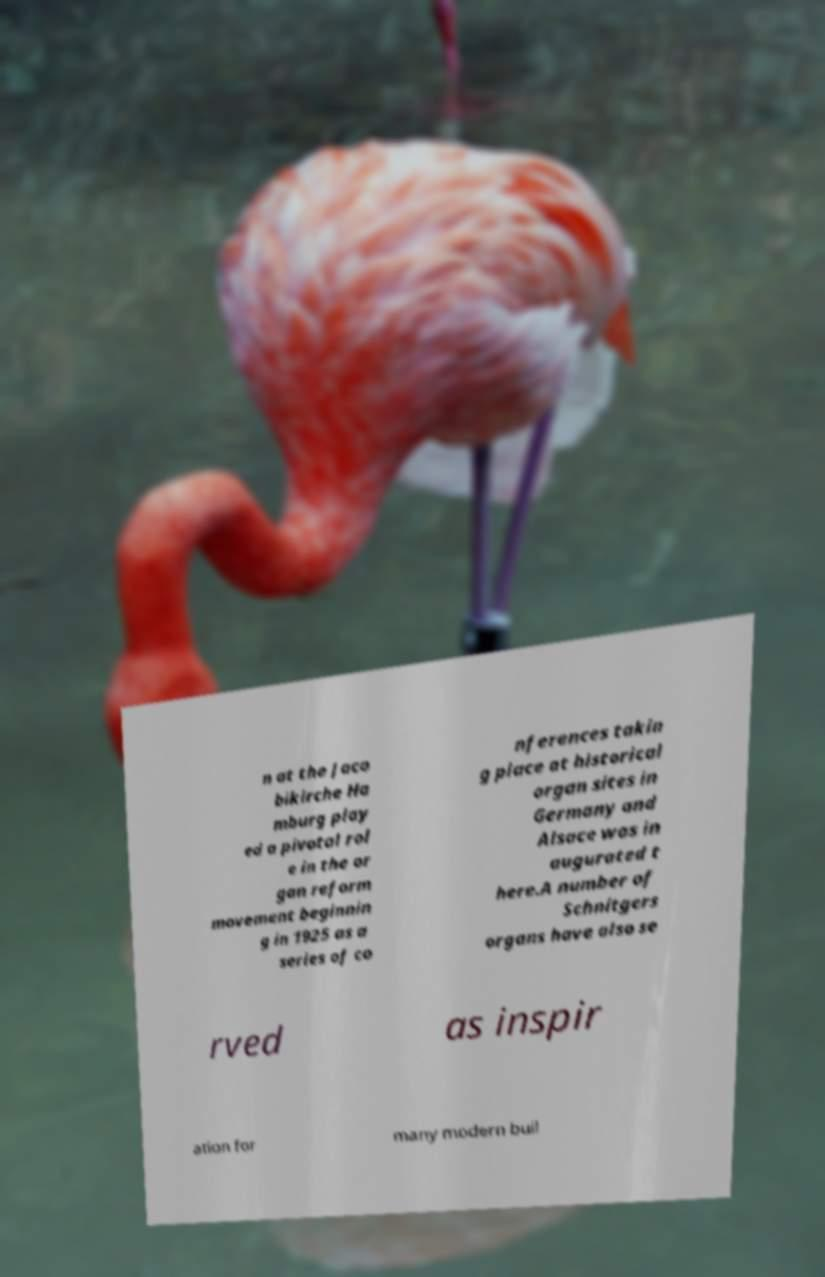What messages or text are displayed in this image? I need them in a readable, typed format. n at the Jaco bikirche Ha mburg play ed a pivotal rol e in the or gan reform movement beginnin g in 1925 as a series of co nferences takin g place at historical organ sites in Germany and Alsace was in augurated t here.A number of Schnitgers organs have also se rved as inspir ation for many modern buil 